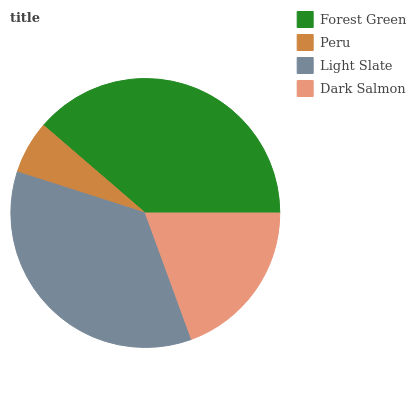Is Peru the minimum?
Answer yes or no. Yes. Is Forest Green the maximum?
Answer yes or no. Yes. Is Light Slate the minimum?
Answer yes or no. No. Is Light Slate the maximum?
Answer yes or no. No. Is Light Slate greater than Peru?
Answer yes or no. Yes. Is Peru less than Light Slate?
Answer yes or no. Yes. Is Peru greater than Light Slate?
Answer yes or no. No. Is Light Slate less than Peru?
Answer yes or no. No. Is Light Slate the high median?
Answer yes or no. Yes. Is Dark Salmon the low median?
Answer yes or no. Yes. Is Peru the high median?
Answer yes or no. No. Is Forest Green the low median?
Answer yes or no. No. 